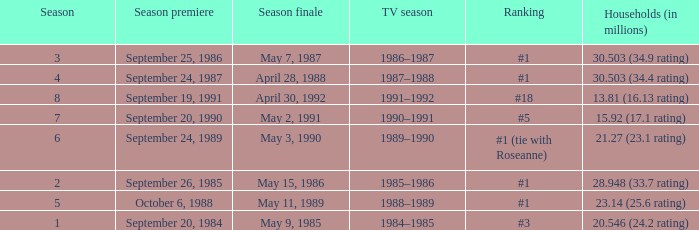Which TV season has a Season smaller than 8, and a Household (in millions) of 15.92 (17.1 rating)? 1990–1991. 